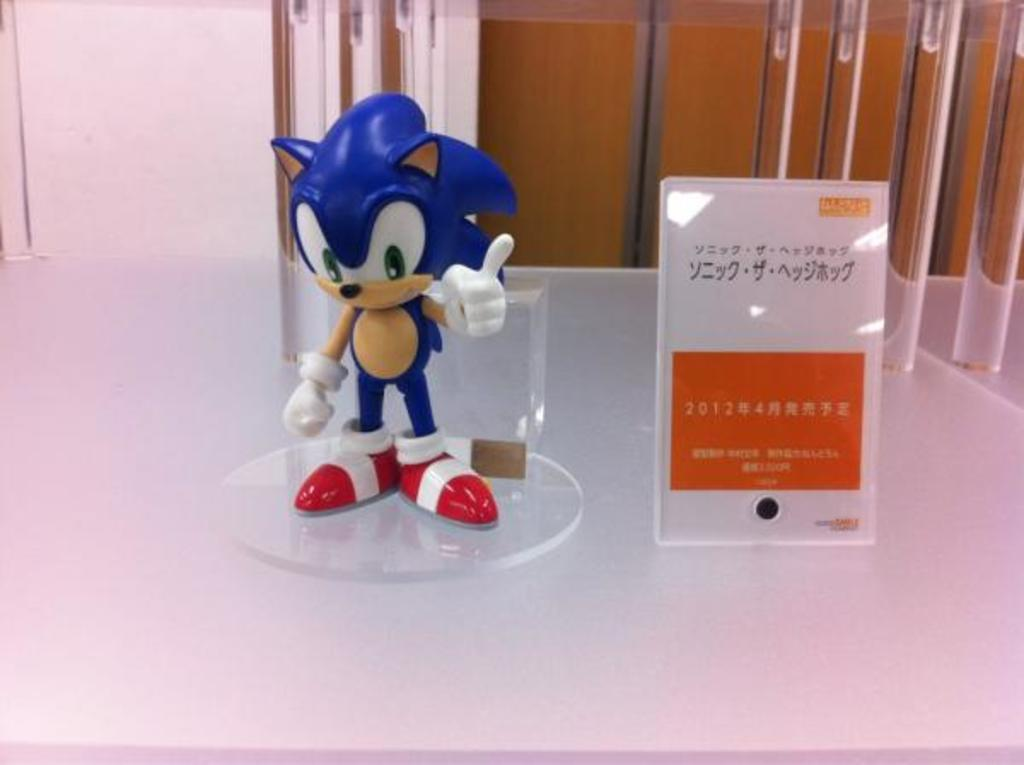What object in the image is designed for play or amusement? There is a toy in the image. What is the surface on which the toy is placed? There is a glass board in the image. How is the toy positioned in relation to the glass board? The toy is placed on the glass board. What type of tent is visible in the image? There is no tent present in the image. Is there a battle taking place between the toy and the glass board in the image? There is no battle depicted in the image; it simply shows a toy placed on a glass board. 